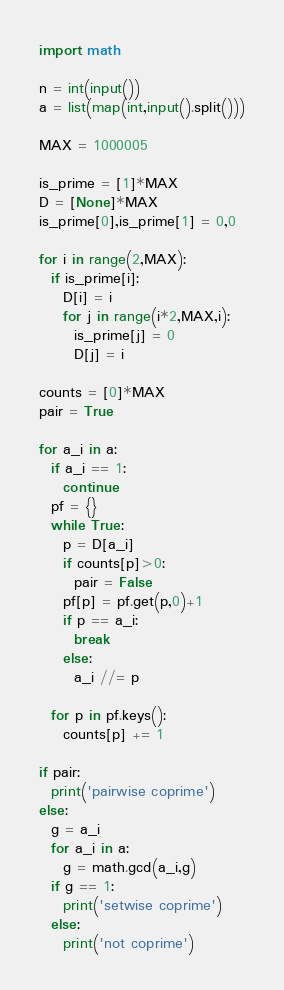<code> <loc_0><loc_0><loc_500><loc_500><_Python_>import math

n = int(input())
a = list(map(int,input().split()))

MAX = 1000005

is_prime = [1]*MAX
D = [None]*MAX
is_prime[0],is_prime[1] = 0,0

for i in range(2,MAX):
  if is_prime[i]:
    D[i] = i
    for j in range(i*2,MAX,i):
      is_prime[j] = 0
      D[j] = i
      
counts = [0]*MAX
pair = True

for a_i in a:
  if a_i == 1:
    continue
  pf = {}
  while True:
    p = D[a_i]
    if counts[p]>0:
      pair = False
    pf[p] = pf.get(p,0)+1
    if p == a_i:
      break
    else:
      a_i //= p
      
  for p in pf.keys():
    counts[p] += 1

if pair:
  print('pairwise coprime')
else:
  g = a_i
  for a_i in a:
    g = math.gcd(a_i,g)
  if g == 1:
    print('setwise coprime')
  else:
    print('not coprime')</code> 